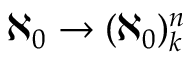Convert formula to latex. <formula><loc_0><loc_0><loc_500><loc_500>\aleph _ { 0 } \rightarrow ( \aleph _ { 0 } ) _ { k } ^ { n }</formula> 